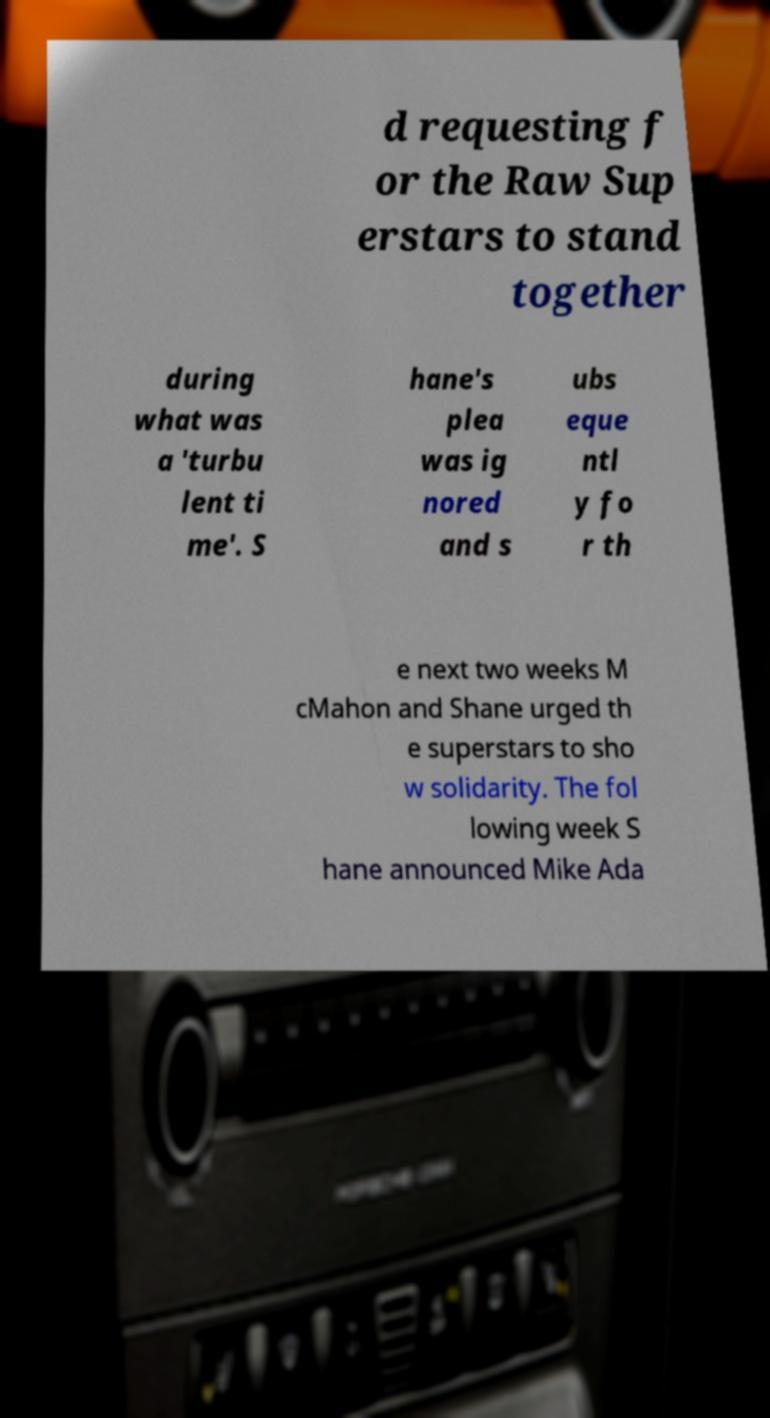For documentation purposes, I need the text within this image transcribed. Could you provide that? d requesting f or the Raw Sup erstars to stand together during what was a 'turbu lent ti me'. S hane's plea was ig nored and s ubs eque ntl y fo r th e next two weeks M cMahon and Shane urged th e superstars to sho w solidarity. The fol lowing week S hane announced Mike Ada 